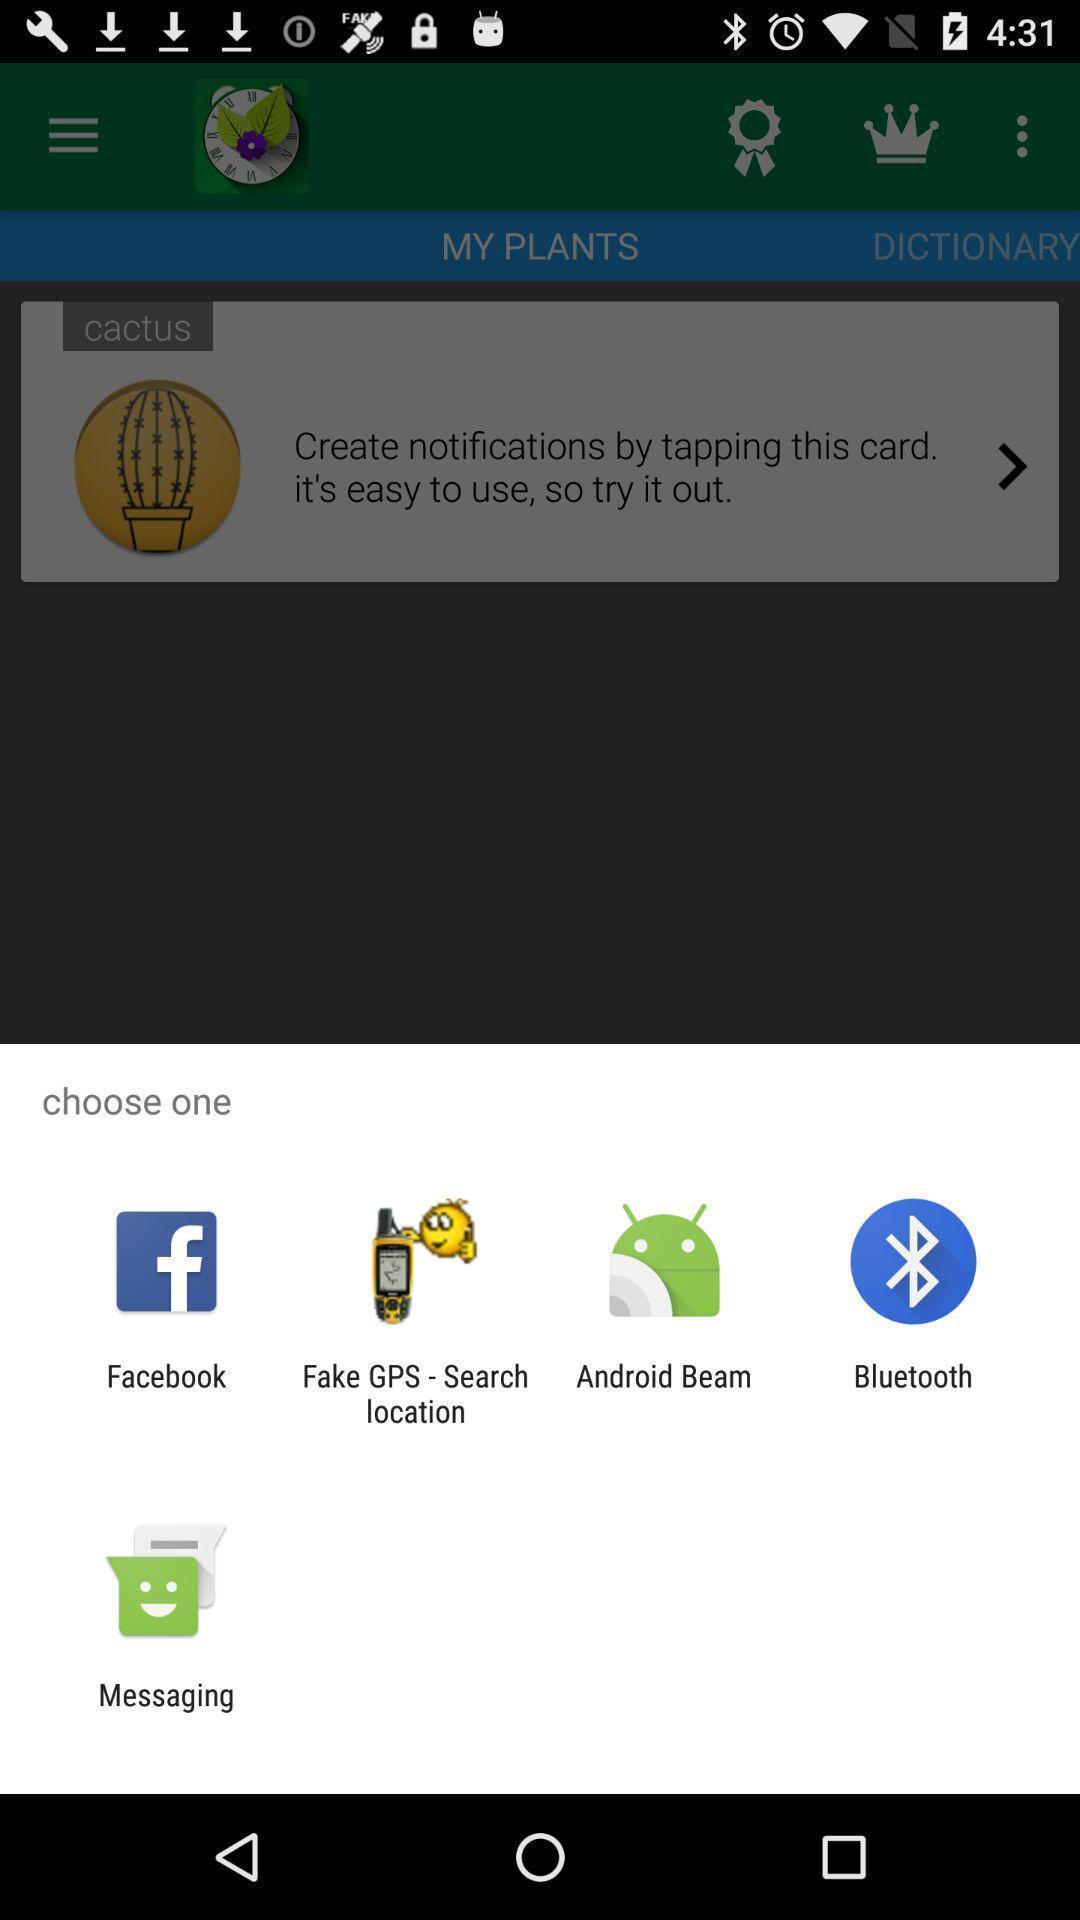Describe the content in this image. Pop-up to choose an app. 